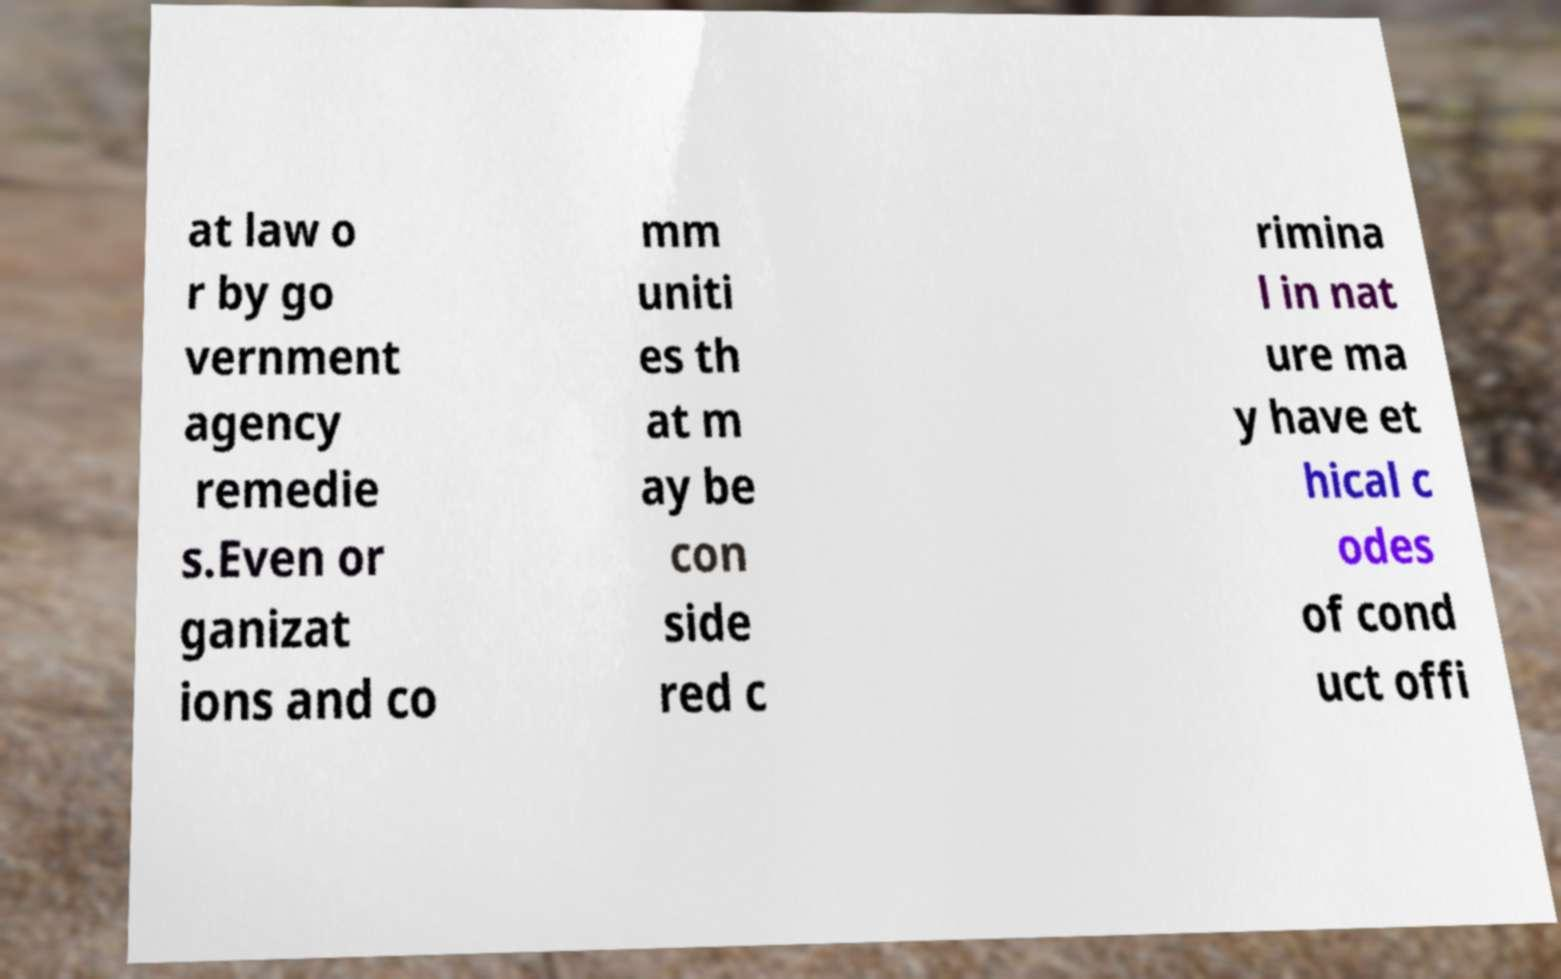For documentation purposes, I need the text within this image transcribed. Could you provide that? at law o r by go vernment agency remedie s.Even or ganizat ions and co mm uniti es th at m ay be con side red c rimina l in nat ure ma y have et hical c odes of cond uct offi 